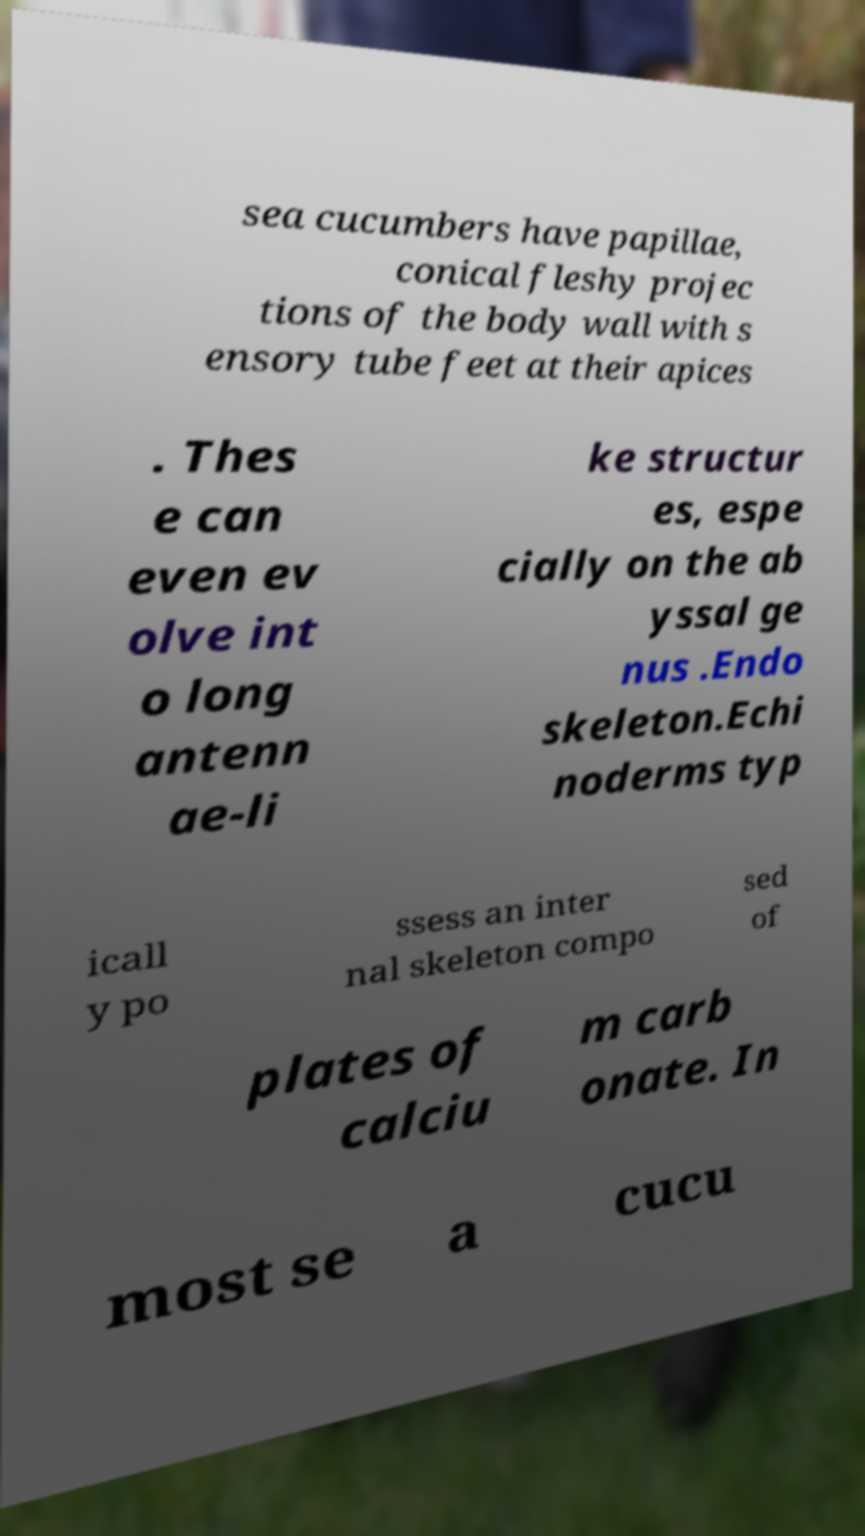Could you extract and type out the text from this image? sea cucumbers have papillae, conical fleshy projec tions of the body wall with s ensory tube feet at their apices . Thes e can even ev olve int o long antenn ae-li ke structur es, espe cially on the ab yssal ge nus .Endo skeleton.Echi noderms typ icall y po ssess an inter nal skeleton compo sed of plates of calciu m carb onate. In most se a cucu 